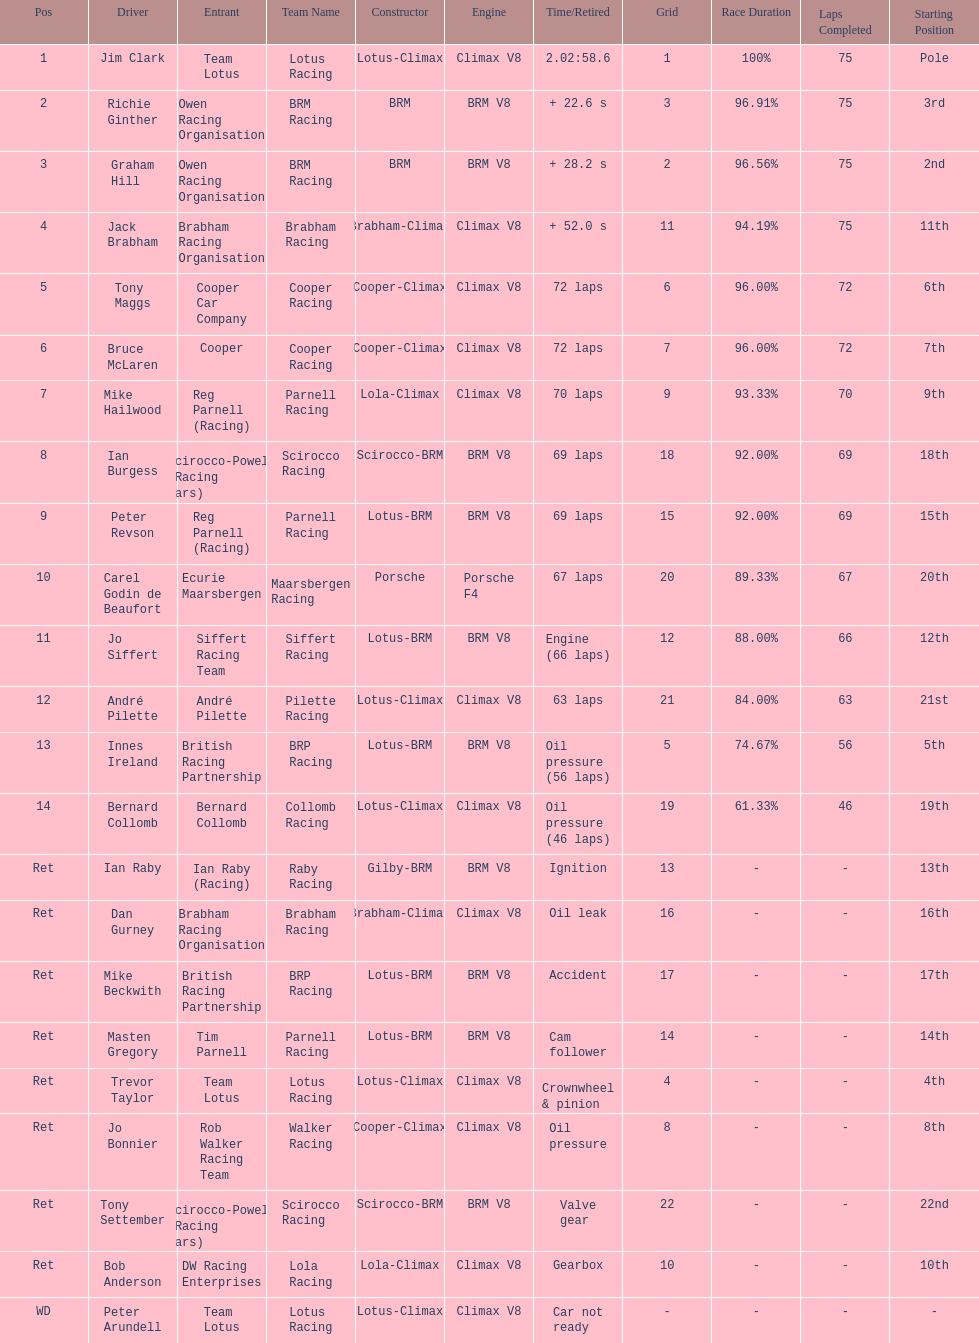Who came in first? Jim Clark. 